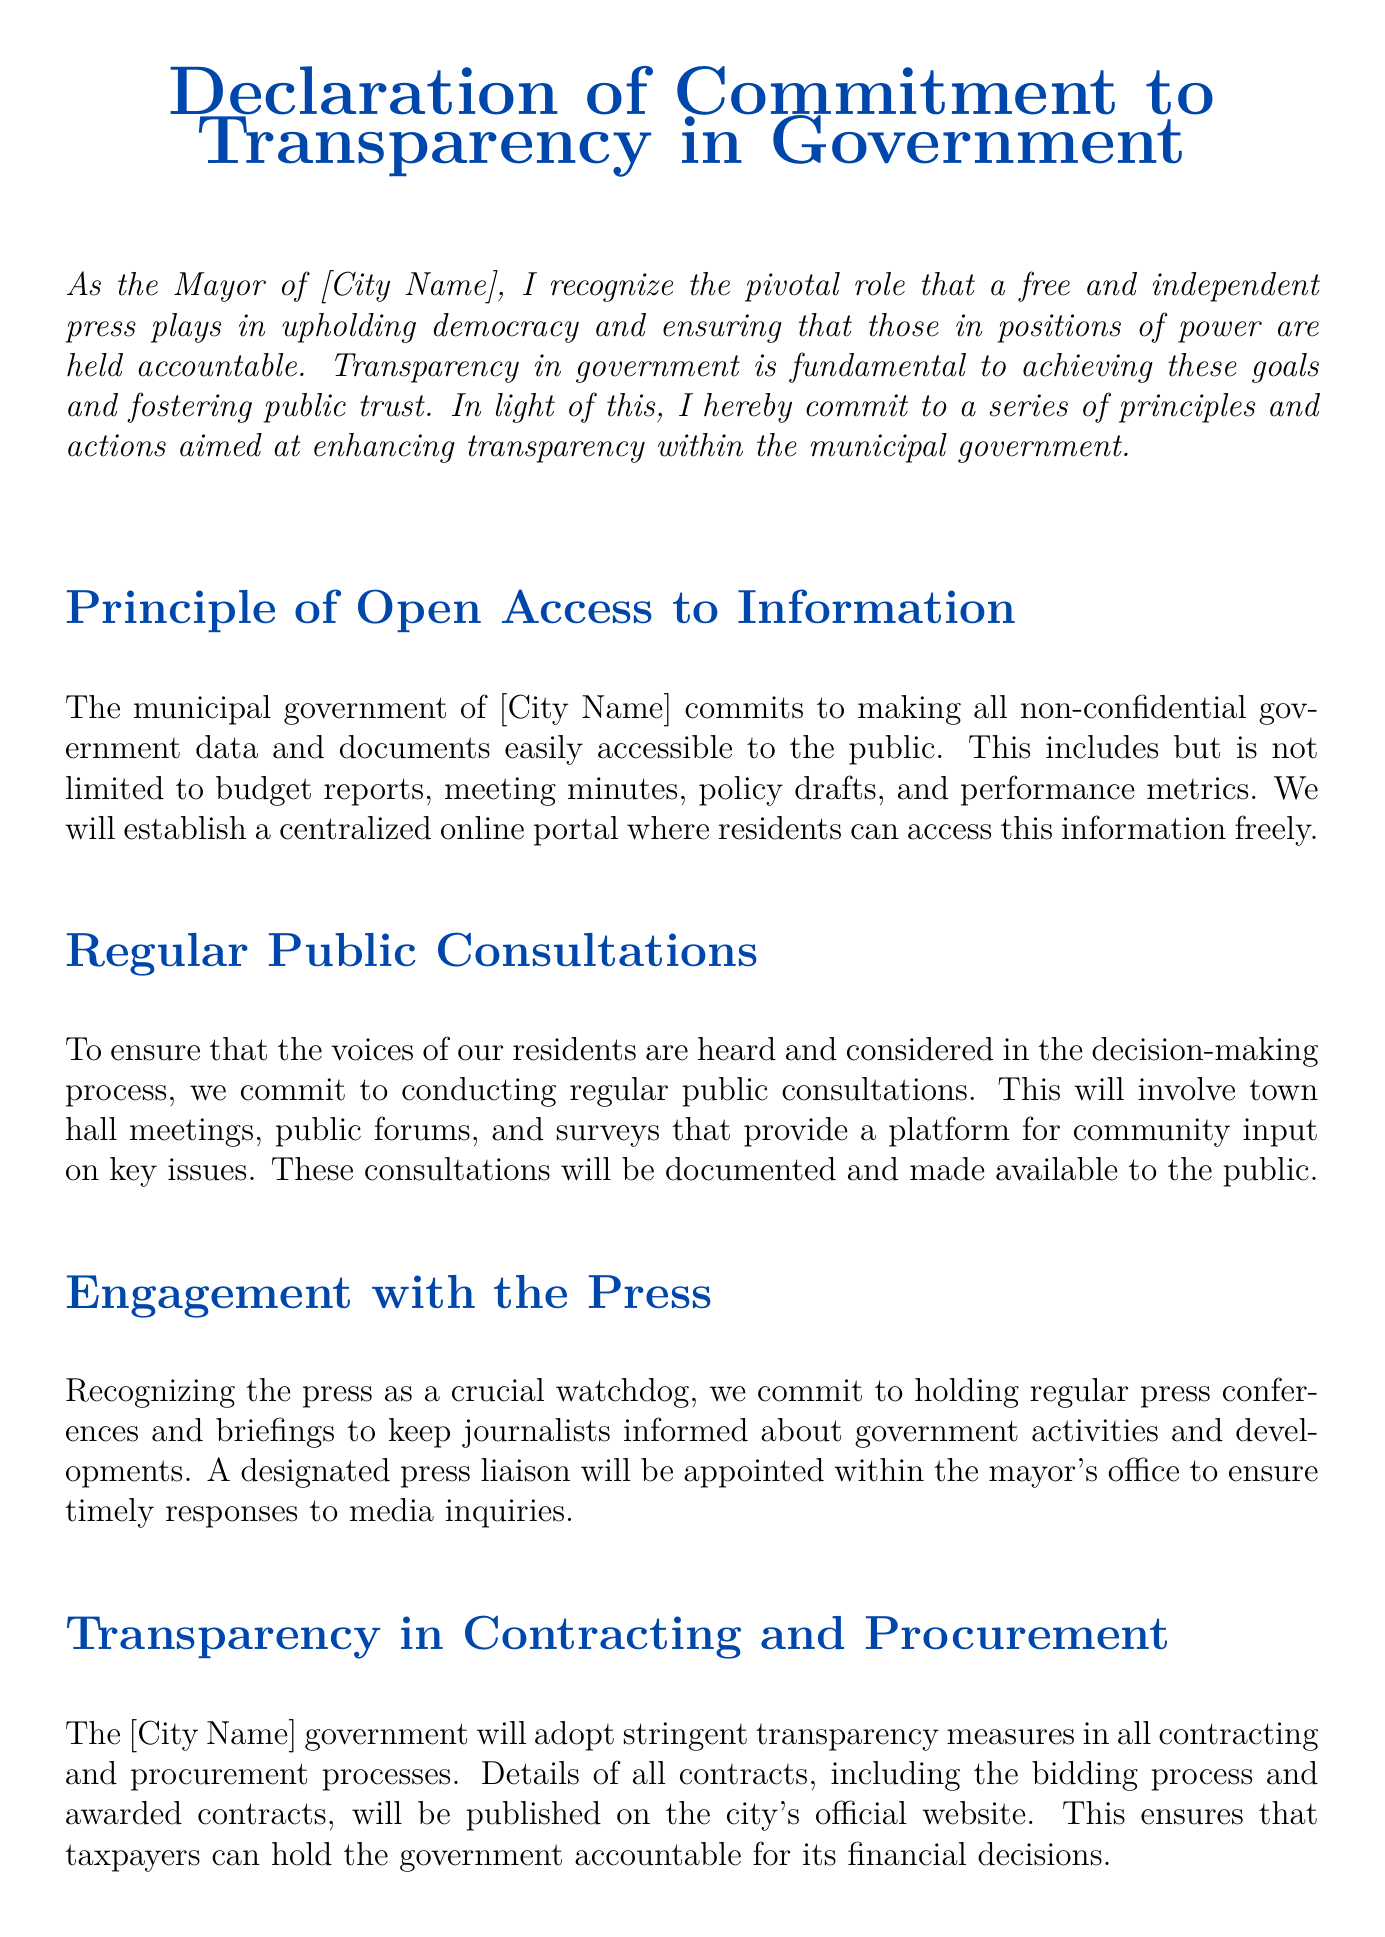what is the title of the document? The title of the document is indicated at the center of the first page, highlighting its main purpose.
Answer: Declaration of Commitment to Transparency in Government who is the author of the document? The author is specified at the bottom of the document as the individual signing it.
Answer: [Mayor's Name] what is the first principle outlined in the document? The first principle is mentioned in the section title describing a commitment to accessibility of information.
Answer: Principle of Open Access to Information how many sections are included in the document? The number of sections can be counted by identifying each section title listed in the document.
Answer: Five what is the purpose of public consultations according to the document? The purpose is explained in relation to involving community input in government decisions.
Answer: To ensure voices of residents are heard what measures are mentioned for whistleblower protections? The document refers to the establishment of certain policies to protect those reporting unethical practices.
Answer: Robust whistleblower protection policies where will the details of all contracts be published? The document specifies a location where contracting details will be made available to the public.
Answer: City's official website what body will handle the reports made by whistleblowers? The document refers to an independent body that will manage and investigate reported issues.
Answer: An independent body how does the document define the role of the press? The document highlights the relationship between the government and the media regarding accountability and oversight.
Answer: Crucial watchdog 